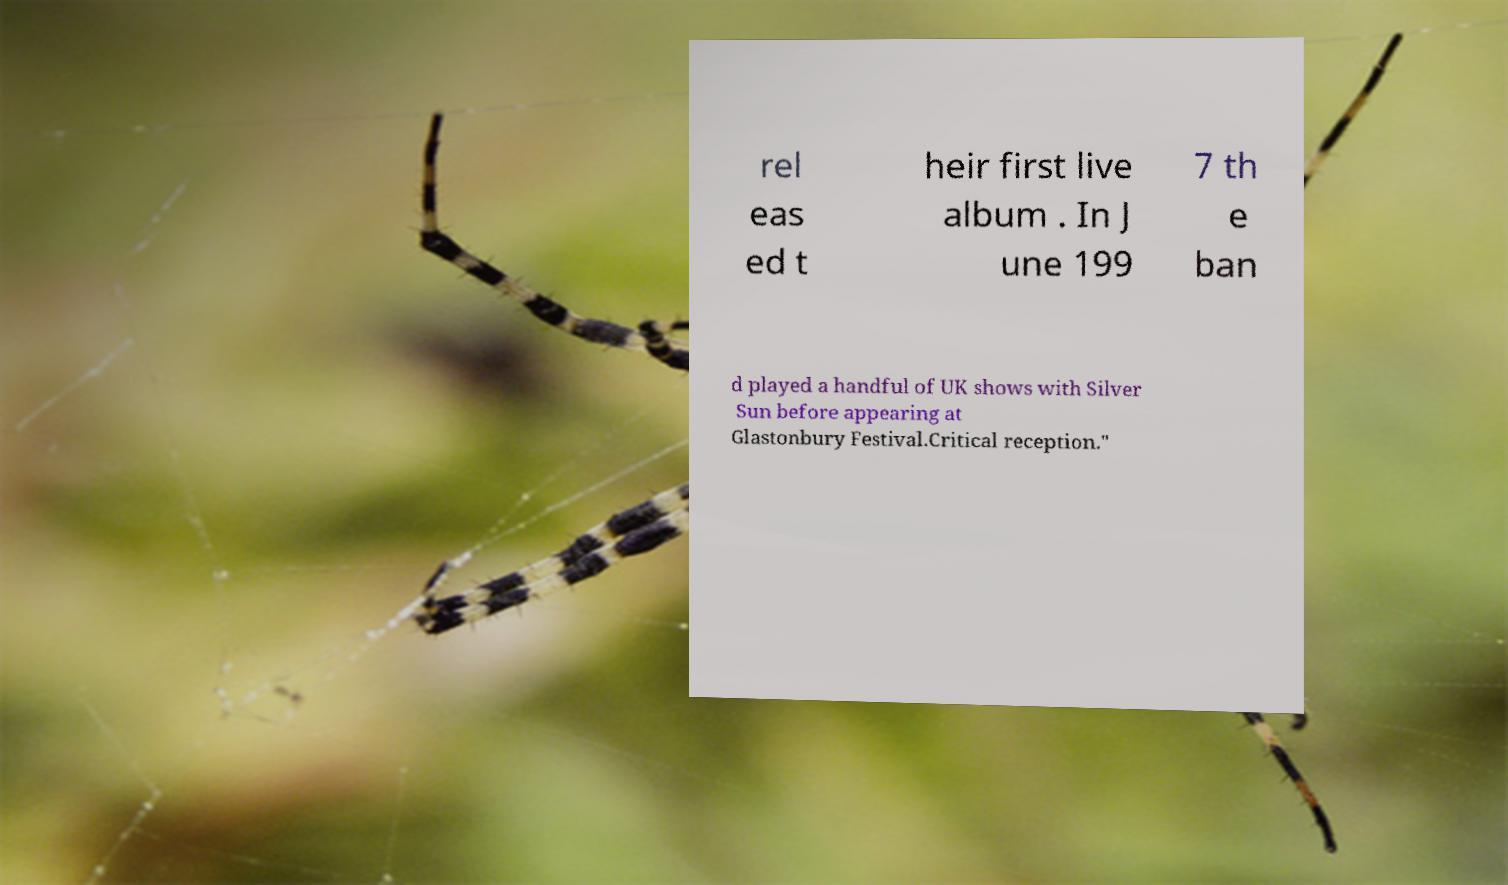There's text embedded in this image that I need extracted. Can you transcribe it verbatim? rel eas ed t heir first live album . In J une 199 7 th e ban d played a handful of UK shows with Silver Sun before appearing at Glastonbury Festival.Critical reception." 